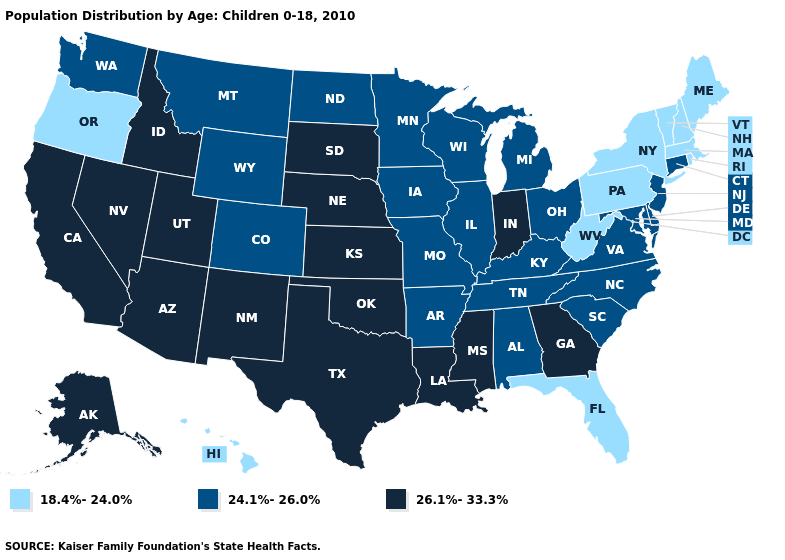What is the value of Florida?
Give a very brief answer. 18.4%-24.0%. Does Georgia have a higher value than Washington?
Keep it brief. Yes. Name the states that have a value in the range 24.1%-26.0%?
Keep it brief. Alabama, Arkansas, Colorado, Connecticut, Delaware, Illinois, Iowa, Kentucky, Maryland, Michigan, Minnesota, Missouri, Montana, New Jersey, North Carolina, North Dakota, Ohio, South Carolina, Tennessee, Virginia, Washington, Wisconsin, Wyoming. Which states have the lowest value in the Northeast?
Give a very brief answer. Maine, Massachusetts, New Hampshire, New York, Pennsylvania, Rhode Island, Vermont. What is the lowest value in states that border New Mexico?
Short answer required. 24.1%-26.0%. Does Maine have the same value as North Carolina?
Keep it brief. No. Among the states that border Montana , which have the highest value?
Answer briefly. Idaho, South Dakota. Name the states that have a value in the range 26.1%-33.3%?
Quick response, please. Alaska, Arizona, California, Georgia, Idaho, Indiana, Kansas, Louisiana, Mississippi, Nebraska, Nevada, New Mexico, Oklahoma, South Dakota, Texas, Utah. Among the states that border New Mexico , does Oklahoma have the highest value?
Concise answer only. Yes. What is the value of Florida?
Give a very brief answer. 18.4%-24.0%. Does New Mexico have a higher value than South Carolina?
Concise answer only. Yes. What is the highest value in the USA?
Be succinct. 26.1%-33.3%. What is the value of Michigan?
Be succinct. 24.1%-26.0%. Name the states that have a value in the range 24.1%-26.0%?
Be succinct. Alabama, Arkansas, Colorado, Connecticut, Delaware, Illinois, Iowa, Kentucky, Maryland, Michigan, Minnesota, Missouri, Montana, New Jersey, North Carolina, North Dakota, Ohio, South Carolina, Tennessee, Virginia, Washington, Wisconsin, Wyoming. Among the states that border Kansas , which have the lowest value?
Quick response, please. Colorado, Missouri. 